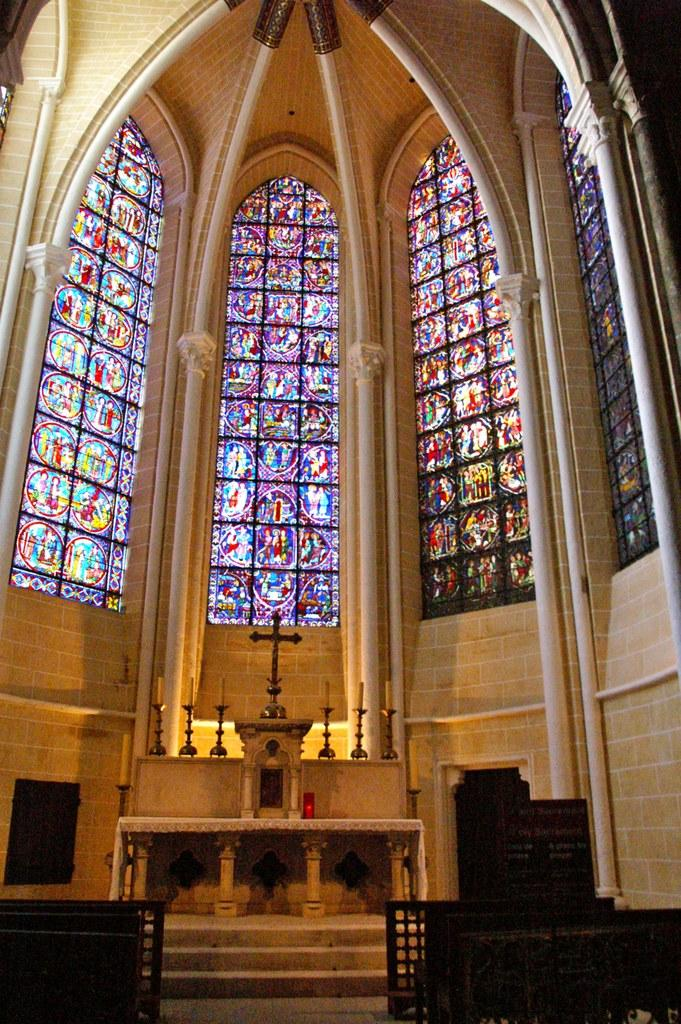What objects are located in the foreground of the image? There are benches in the foreground of the image. What can be seen in the middle of the image? There are candles and a plus symbol in the middle of the image. What type of window is present at the top of the image? There is a colored glass window at the top of the image. What type of brush is used to clean the candles in the image? There is no brush present in the image, and the candles are not being cleaned. 